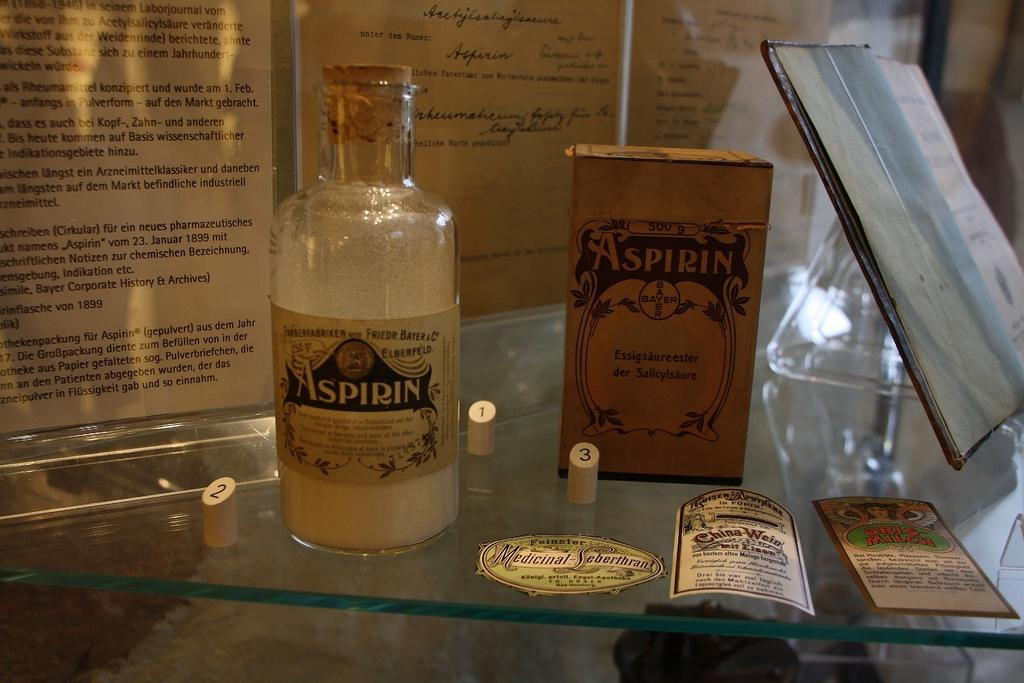<image>
Present a compact description of the photo's key features. On old bottle of Aspirin with the various packaging and labels. 